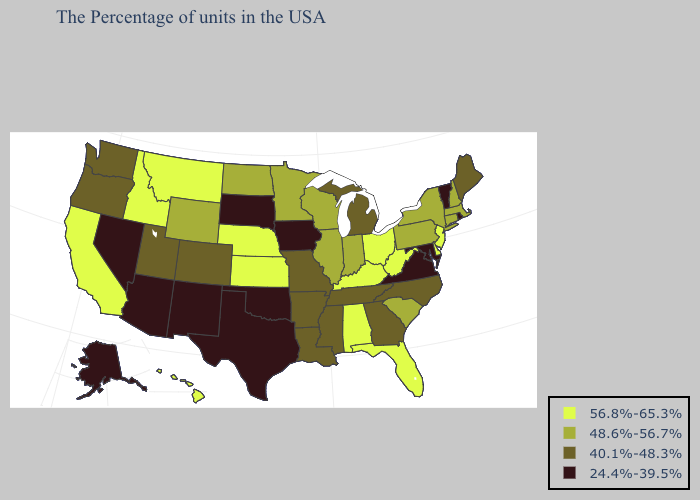What is the value of Pennsylvania?
Keep it brief. 48.6%-56.7%. Name the states that have a value in the range 40.1%-48.3%?
Quick response, please. Maine, North Carolina, Georgia, Michigan, Tennessee, Mississippi, Louisiana, Missouri, Arkansas, Colorado, Utah, Washington, Oregon. Does California have the highest value in the USA?
Keep it brief. Yes. Does Tennessee have a higher value than Colorado?
Quick response, please. No. How many symbols are there in the legend?
Concise answer only. 4. Does West Virginia have the highest value in the USA?
Keep it brief. Yes. Does Mississippi have the lowest value in the USA?
Quick response, please. No. How many symbols are there in the legend?
Quick response, please. 4. Does Wyoming have the same value as North Dakota?
Quick response, please. Yes. Name the states that have a value in the range 56.8%-65.3%?
Answer briefly. New Jersey, Delaware, West Virginia, Ohio, Florida, Kentucky, Alabama, Kansas, Nebraska, Montana, Idaho, California, Hawaii. What is the highest value in the USA?
Quick response, please. 56.8%-65.3%. Name the states that have a value in the range 24.4%-39.5%?
Concise answer only. Rhode Island, Vermont, Maryland, Virginia, Iowa, Oklahoma, Texas, South Dakota, New Mexico, Arizona, Nevada, Alaska. Which states have the lowest value in the West?
Keep it brief. New Mexico, Arizona, Nevada, Alaska. How many symbols are there in the legend?
Be succinct. 4. What is the highest value in states that border Louisiana?
Answer briefly. 40.1%-48.3%. 